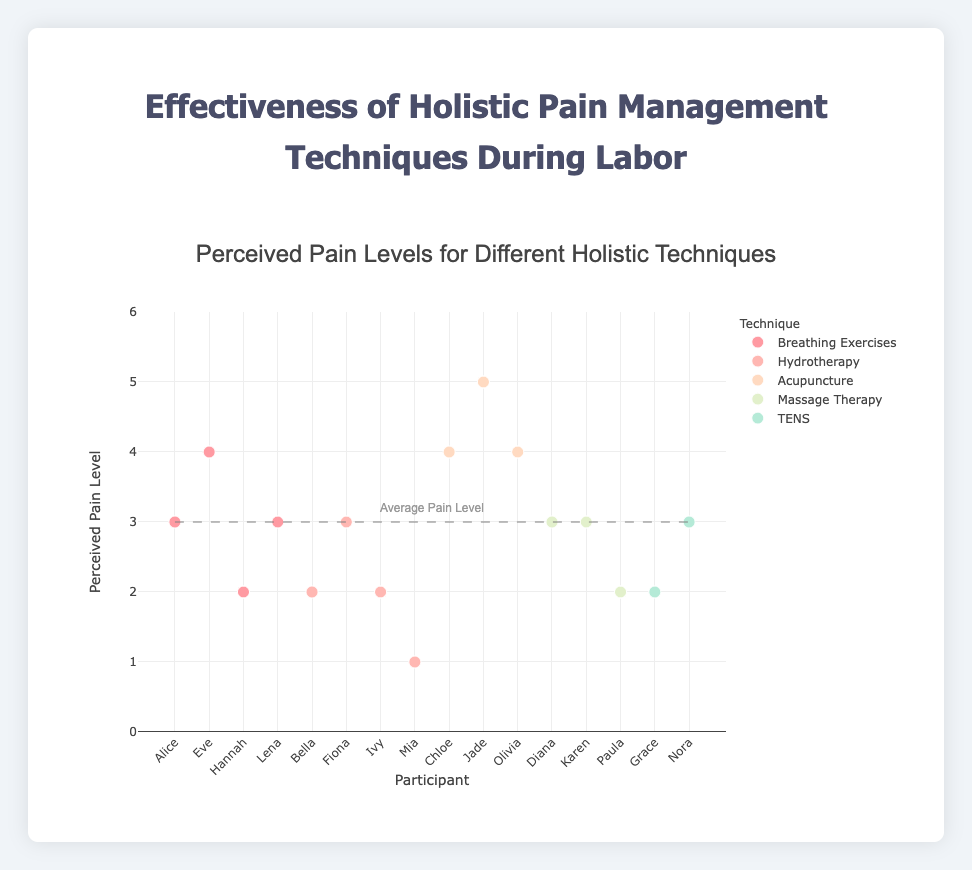What is the title of the plot? The title is usually located at the top of the plot. In this case, the title is "Effectiveness of Holistic Pain Management Techniques During Labor."
Answer: Effectiveness of Holistic Pain Management Techniques During Labor What does the x-axis represent? The label on the x-axis indicates it represents the participants. Each participant's data point is shown along this axis.
Answer: Participant What does the y-axis represent? The label on the y-axis indicates it represents the perceived pain levels, which range from 0 to 6.
Answer: Perceived Pain Level How many techniques are represented in this scatter plot? Each technique has a distinct color and is represented in the legend. By counting the unique colors or legend entries, one can identify the number of techniques.
Answer: 6 Which technique has the lowest perceived pain level for any participant? By examining the y-axis for the lowest value and identifying the corresponding technique through color coding in the legend, we see that "Hydrotherapy" has the lowest perceived pain level of 1.
Answer: Hydrotherapy What's the average perceived pain level indicated by the trend line? Referring to the line drawn on the plot and the annotation, we can see that the average perceived pain level is marked at 3.
Answer: 3 Which participants used acupuncture, and what were their perceived pain levels? By matching the color for Acupuncture from the legend to the data points, we identify the participants and corresponding y-values. Participants Chloe, Jade, and Olivia used acupuncture, with perceived pain levels of 4, 5, and 4 respectively.
Answer: Chloe (4), Jade (5), Olivia (4) Which technique shows the most consistency in perceived pain levels among participants? Consistency can be gauged by how close the pain levels are to each other for each technique. By examining the spread of data points for each colored group, "Hydrotherapy" appears to be the most consistent, with most perceived pain levels close to 2.
Answer: Hydrotherapy How does the effectiveness of breathing exercises compare to that of TENS in terms of perceived pain levels? By comparing the y-values (perceived pain levels) for the data points representing Breathing Exercises and TENS, Breathing Exercises' values range from 2 to 4, while TENS is between 2 and 3. Thus, TENS generally results in lower perceived pain levels.
Answer: TENS generally results in lower perceived pain levels Which technique had the highest individual perceived pain level, and what was the value? By checking the y-axis for the highest value and matching it with the corresponding colored data point, "Acupuncture" has the highest individual perceived pain level of 5.
Answer: Acupuncture (5) 